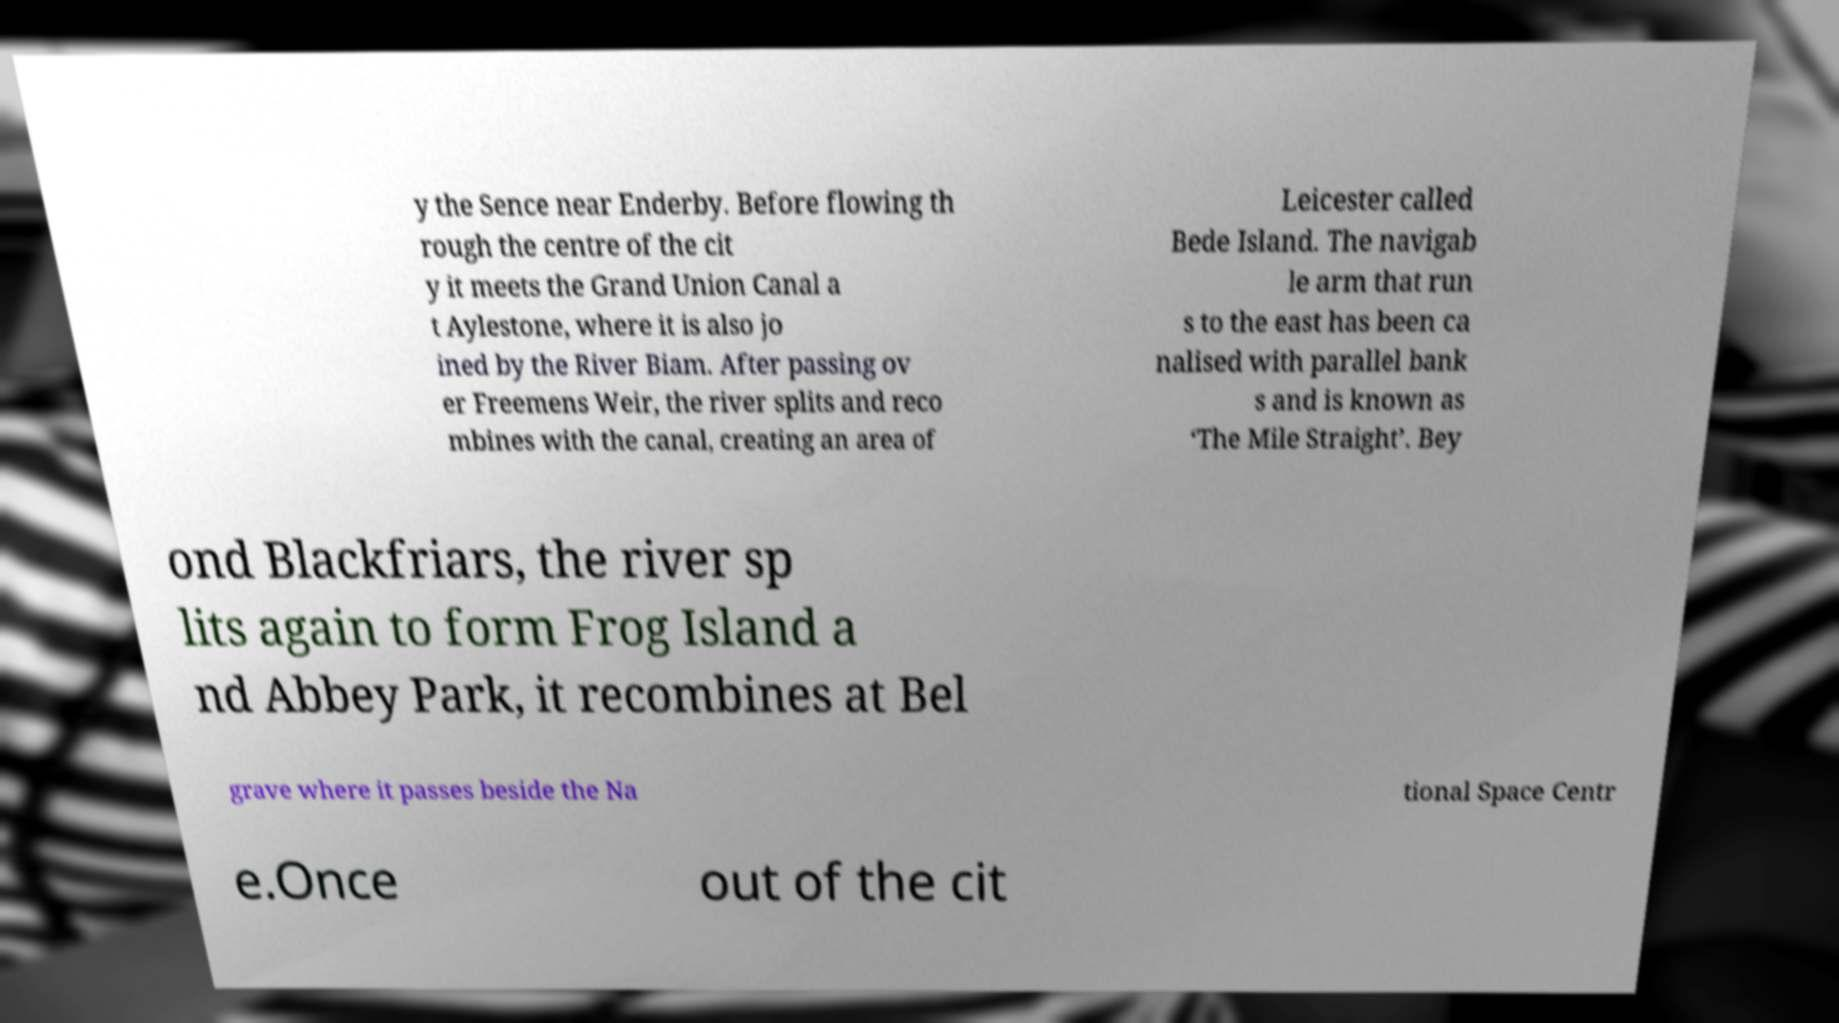Please identify and transcribe the text found in this image. y the Sence near Enderby. Before flowing th rough the centre of the cit y it meets the Grand Union Canal a t Aylestone, where it is also jo ined by the River Biam. After passing ov er Freemens Weir, the river splits and reco mbines with the canal, creating an area of Leicester called Bede Island. The navigab le arm that run s to the east has been ca nalised with parallel bank s and is known as ‘The Mile Straight’. Bey ond Blackfriars, the river sp lits again to form Frog Island a nd Abbey Park, it recombines at Bel grave where it passes beside the Na tional Space Centr e.Once out of the cit 